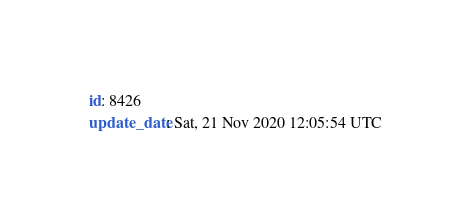<code> <loc_0><loc_0><loc_500><loc_500><_YAML_>id: 8426
update_date: Sat, 21 Nov 2020 12:05:54 UTC
</code> 